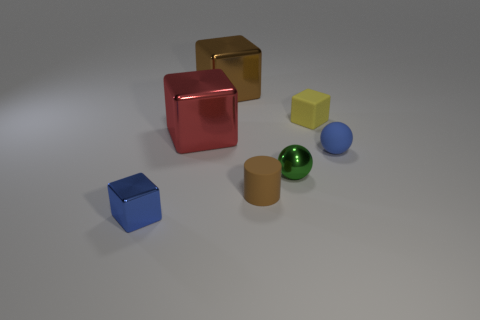Add 1 yellow metal cubes. How many objects exist? 8 Subtract all cylinders. How many objects are left? 6 Add 5 small brown things. How many small brown things are left? 6 Add 4 small brown things. How many small brown things exist? 5 Subtract 0 cyan balls. How many objects are left? 7 Subtract all small shiny cubes. Subtract all tiny brown rubber cylinders. How many objects are left? 5 